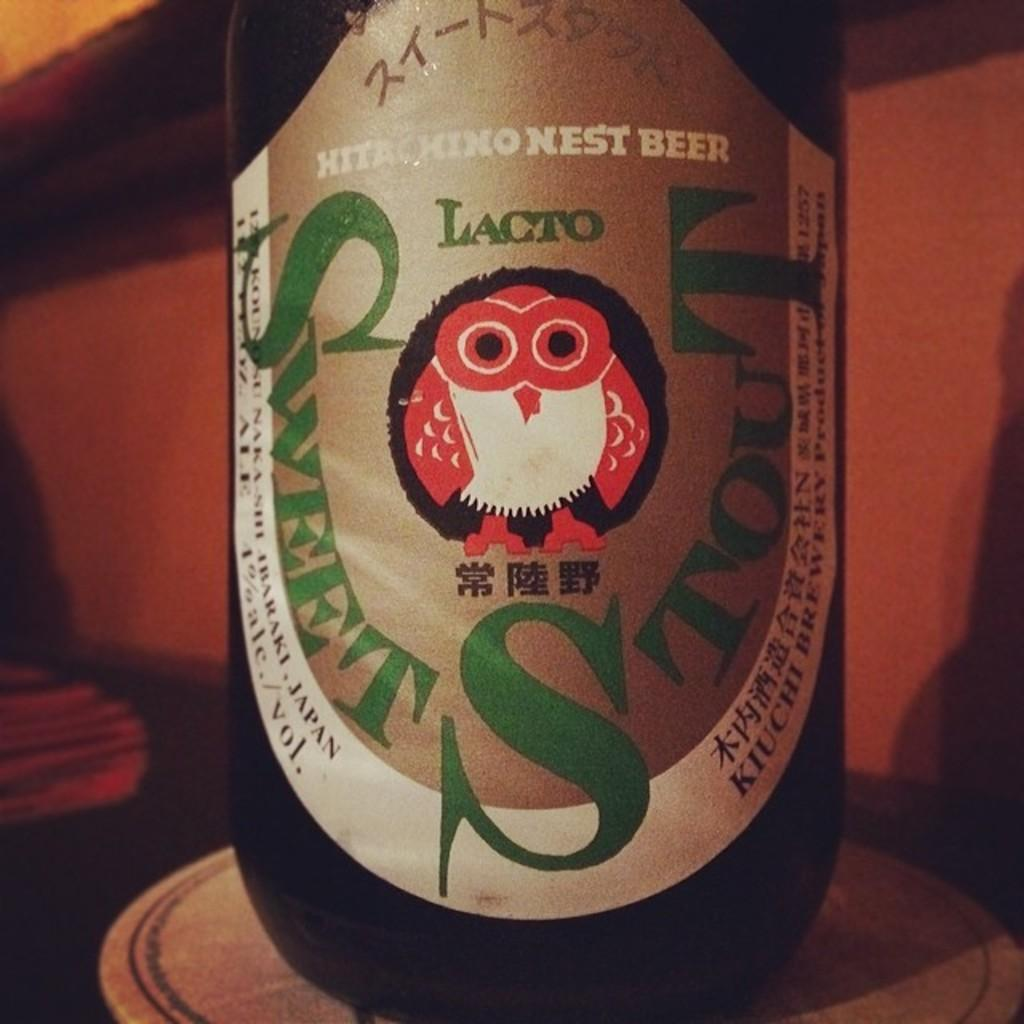What is on the beer bottle in the image? There is a sticker on a beer bottle in the image. What shape is the sticker on the beer bottle? The sticker is in the shape of an owl. What colors are used on the owl sticker? The owl sticker has red and white colors. How many cents can be seen on the owl sticker in the image? There are no cents depicted on the owl sticker in the image. 